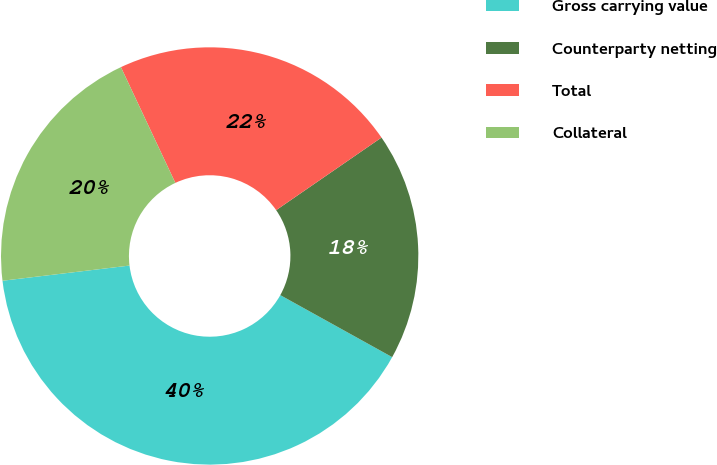Convert chart to OTSL. <chart><loc_0><loc_0><loc_500><loc_500><pie_chart><fcel>Gross carrying value<fcel>Counterparty netting<fcel>Total<fcel>Collateral<nl><fcel>40.05%<fcel>17.66%<fcel>22.39%<fcel>19.9%<nl></chart> 